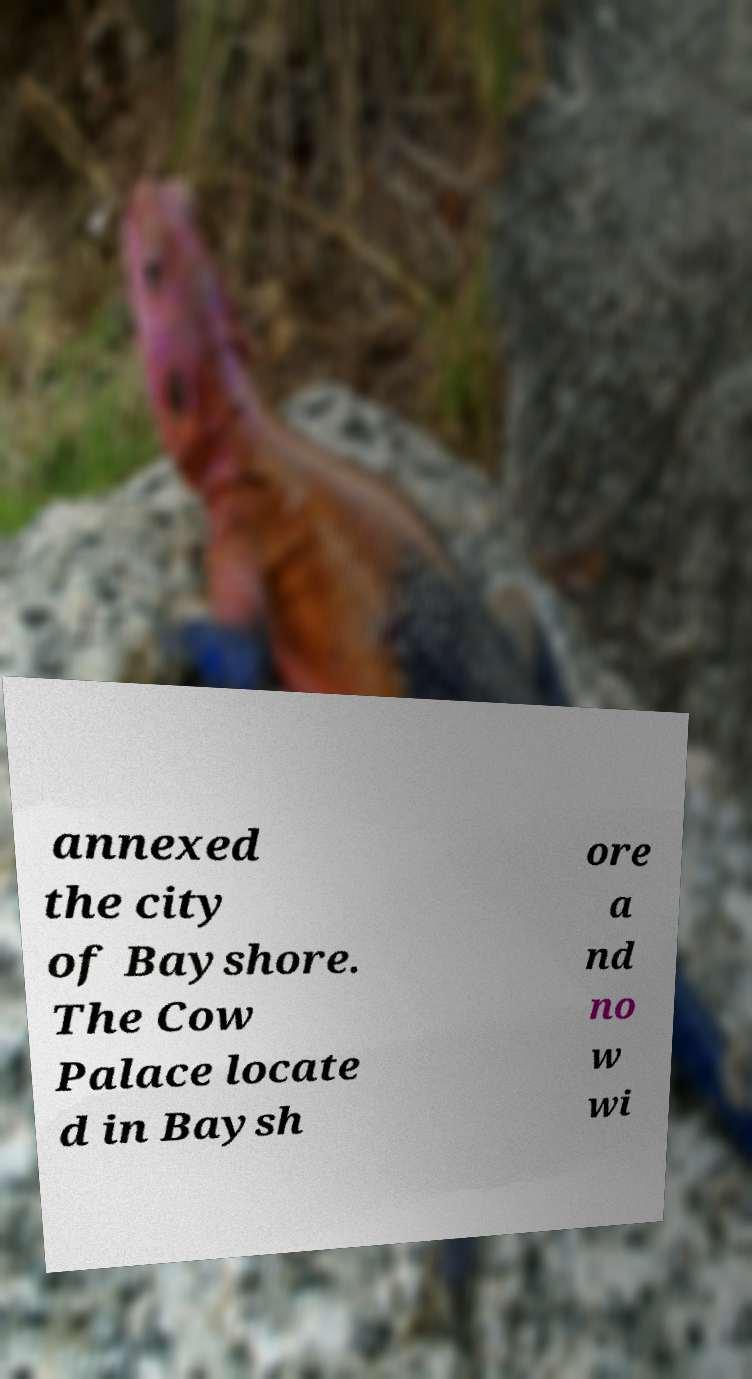Could you extract and type out the text from this image? annexed the city of Bayshore. The Cow Palace locate d in Baysh ore a nd no w wi 